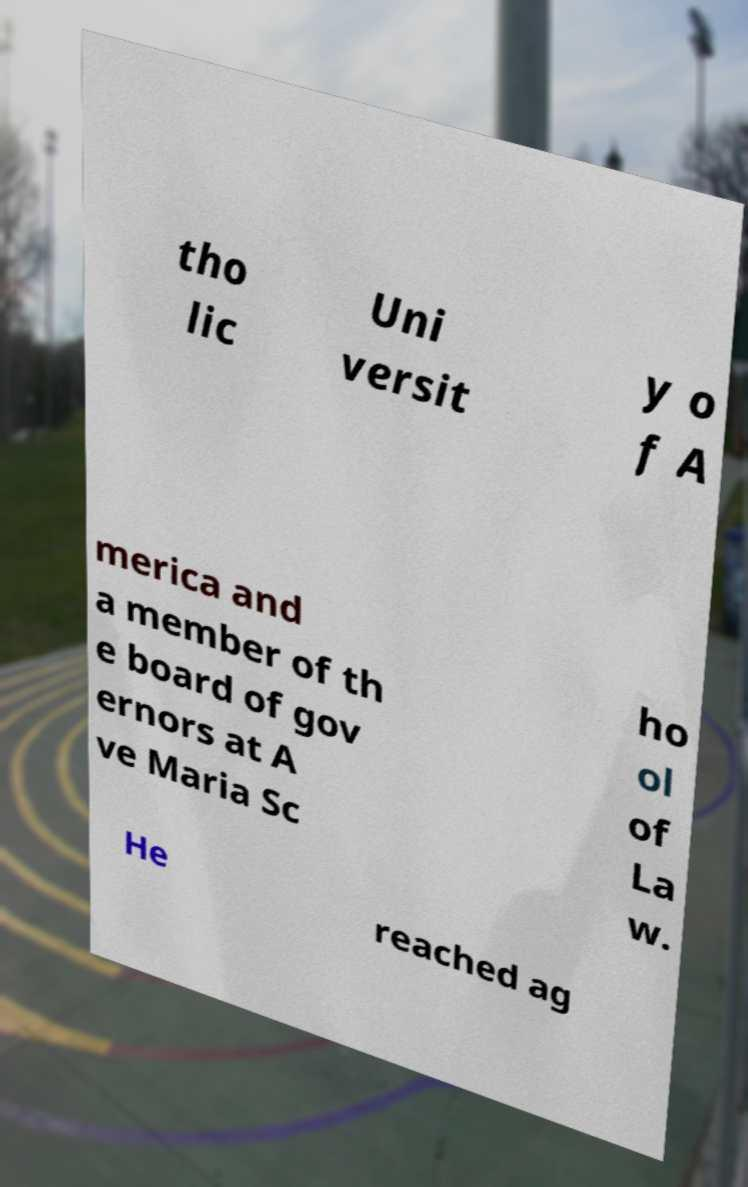What messages or text are displayed in this image? I need them in a readable, typed format. tho lic Uni versit y o f A merica and a member of th e board of gov ernors at A ve Maria Sc ho ol of La w. He reached ag 